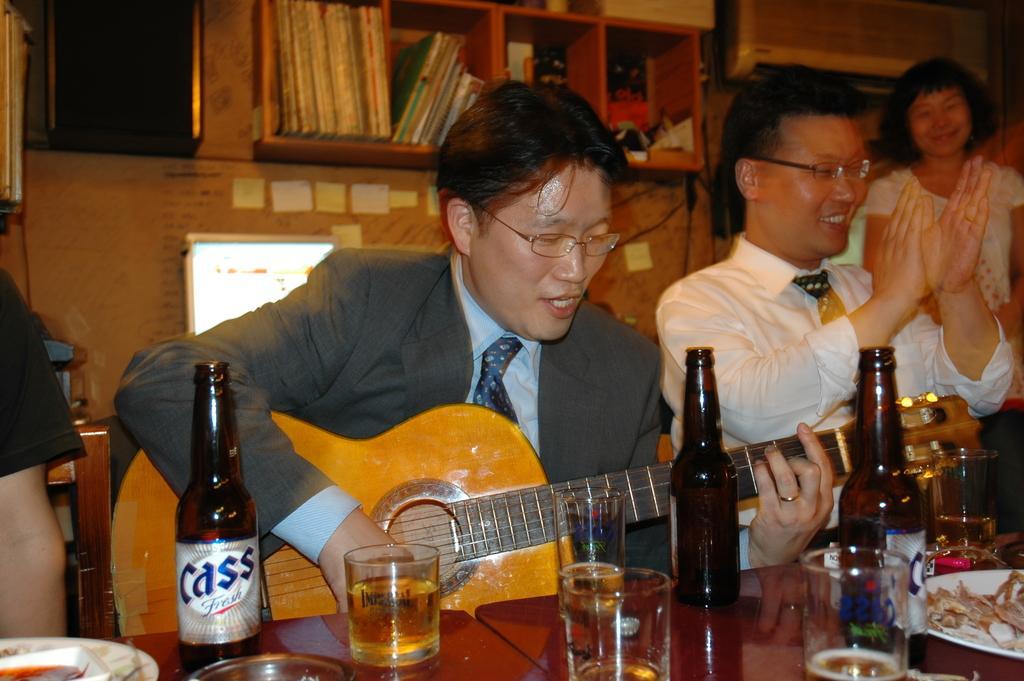Can you describe this image briefly? There is a table,on that there are bottles ,some glasses which contains wine and some people are sitting on the chair and and a man holding a music instrument and a man is clapping and a women standing behind the man in the background there is a rack in which books are placed. 